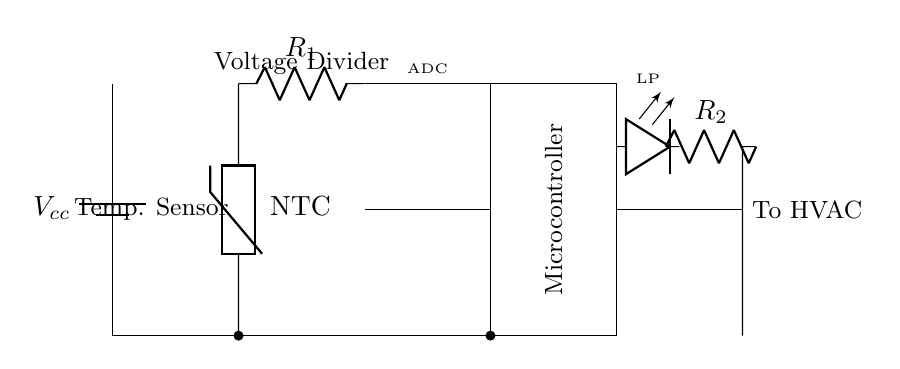What type of temperature sensor is used in this circuit? The circuit diagram shows a thermistor labeled as NTC, which stands for Negative Temperature Coefficient. NTC thermistors decrease in resistance as the temperature increases, making them suitable for temperature sensing applications.
Answer: NTC thermistor What does the microcontroller do in this circuit? The microcontroller processes the analog signals from the temperature sensor via the ADC input. It converts these signals into digital data that can be used for decision-making, control, and communication with the HVAC system.
Answer: Processes temperature data How many resistors are present in the circuit? The circuit diagram indicates two resistors: R1 in the voltage divider and R2 as part of the low-power indicator. Count these two components to determine the total.
Answer: Two resistors What is the purpose of the sleep mode in this circuit? The sleep mode is implemented as an energy-saving feature, allowing the microcontroller to reduce power consumption when the system is idle. It minimizes energy use while still being able to wake up and perform tasks as needed.
Answer: Energy-saving feature What is the output of the circuit connected to? The output from the microcontroller is connected to the HVAC system, indicating that it controls the heating and cooling based on the temperature readings. This ensures that the climate control is efficient and responsive to the environment.
Answer: HVAC system What type of resistor is labeled R1 and R2? R1 is part of the voltage divider with the thermistor, while R2 is part of the low-power indicator LED circuit. The specific types are not labeled in the diagram but knowing that R1 would typically belong to a voltage divider context and R2 is used for an LED helps understand their roles.
Answer: Voltage divider and LED indicator What is the primary function of the voltage divider in the circuit? The voltage divider, consisting of R1 and the thermistor, provides a variable voltage that corresponds to the temperature sensed. It creates an analog voltage output that is proportional to the resistance of the thermistor, which is read by the microcontroller.
Answer: Provides temperature voltage 